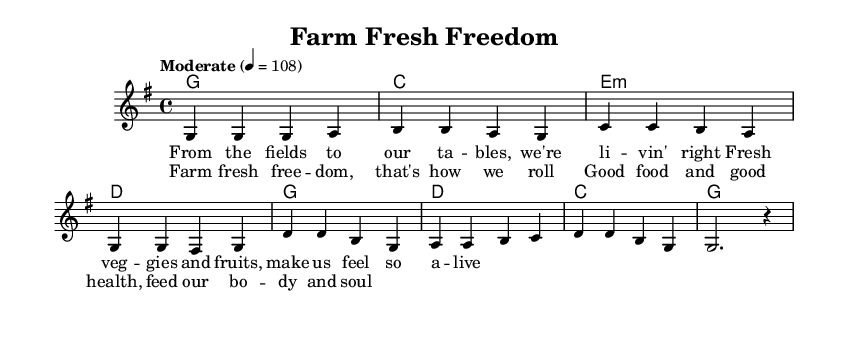What is the key signature of this music? The key signature is G major, which has one sharp (F#). It can be identified by looking at the beginning of the staff, where the sharp symbol is indicated.
Answer: G major What is the time signature of this music? The time signature is 4/4, which is indicated by the two numbers at the beginning of the score. The top number represents four beats in a measure, and the bottom number indicates that a quarter note gets one beat.
Answer: 4/4 What is the tempo marking of this music? The tempo marking is "Moderate" with a metronome marking of 4 equals 108. This can be found near the top of the score, indicating the intended speed of the music.
Answer: Moderate, 4 = 108 In how many measures does the verse consist? The verse consists of four measures, as indicated by the grouping of notes and the absence of any other section indicators. Each measure is separated by vertical lines, making it easy to count them.
Answer: 4 measures What is the primary theme of the lyrics? The primary theme of the lyrics is about healthy living, specifically emphasizing fresh food sourced from local farms. This can be inferred from the words "farm fresh" and the focus on vegetables and fruits.
Answer: Healthy living What chords are used in the chorus? The chords used in the chorus are G, D, C, and G. This can be determined by looking at the chord symbols written above the melody line during the chorus section.
Answer: G, D, C, G How many distinct sections are present in the song? The song has two distinct sections: the verse and the chorus. Each section has its own melody and lyrics, which can be identified as they are labeled separately in the score.
Answer: 2 sections 